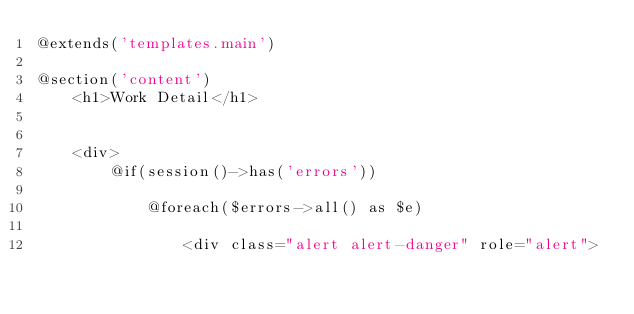<code> <loc_0><loc_0><loc_500><loc_500><_PHP_>@extends('templates.main')

@section('content')
    <h1>Work Detail</h1>


    <div>
        @if(session()->has('errors'))

            @foreach($errors->all() as $e)

                <div class="alert alert-danger" role="alert"></code> 